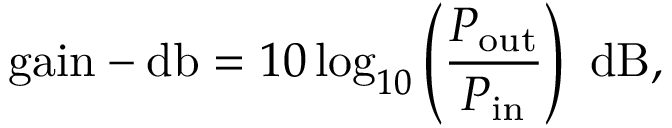<formula> <loc_0><loc_0><loc_500><loc_500>{ g a i n - d b } = 1 0 \log _ { 1 0 } \left ( { \frac { P _ { o u t } } { P _ { i n } } } \right ) { d B } ,</formula> 